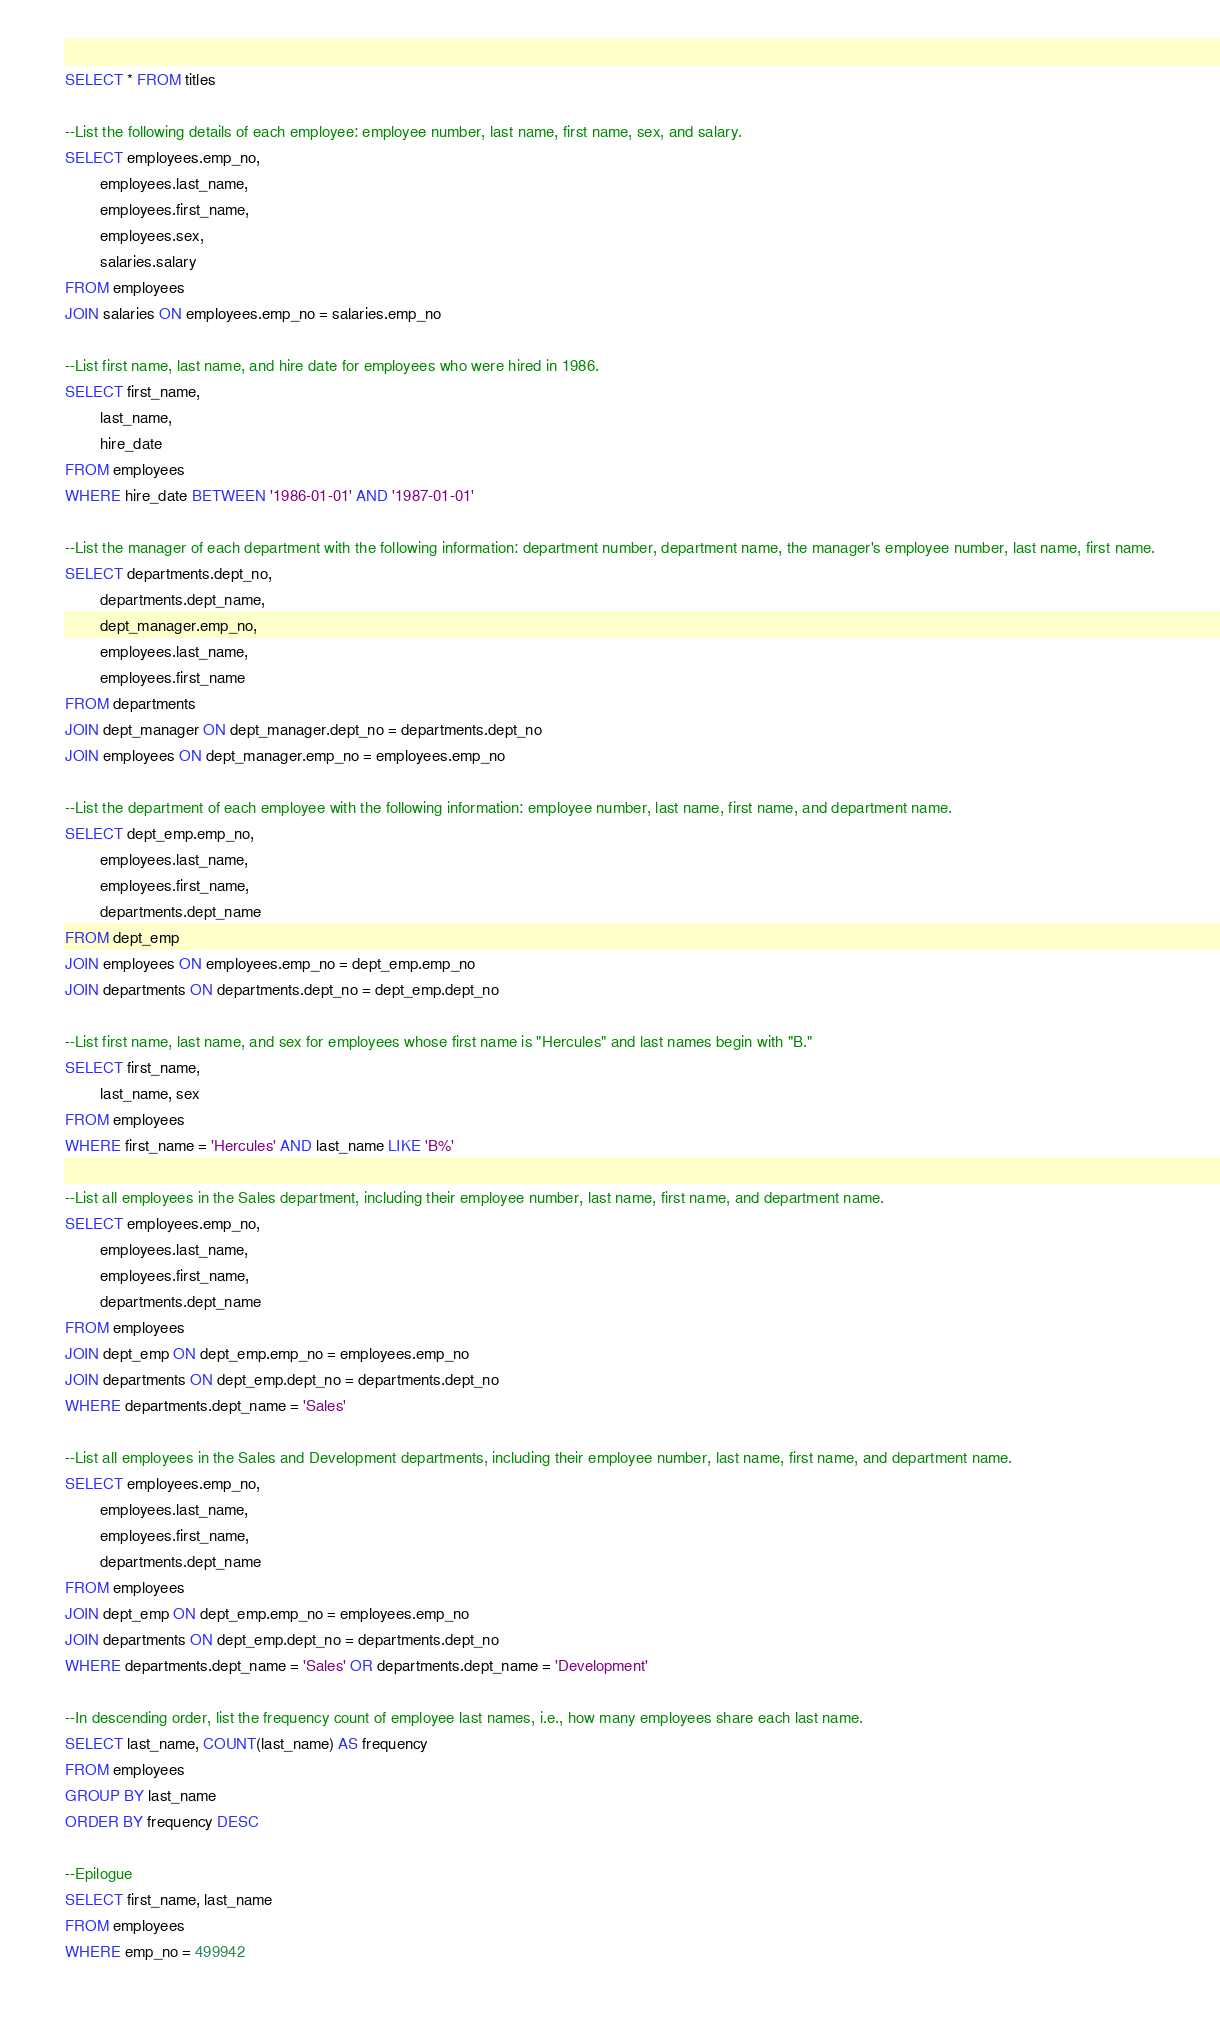Convert code to text. <code><loc_0><loc_0><loc_500><loc_500><_SQL_>SELECT * FROM titles

--List the following details of each employee: employee number, last name, first name, sex, and salary.
SELECT employees.emp_no,
		employees.last_name,
		employees.first_name,
		employees.sex,
		salaries.salary
FROM employees
JOIN salaries ON employees.emp_no = salaries.emp_no

--List first name, last name, and hire date for employees who were hired in 1986.
SELECT first_name,
		last_name,
		hire_date 
FROM employees
WHERE hire_date BETWEEN '1986-01-01' AND '1987-01-01'

--List the manager of each department with the following information: department number, department name, the manager's employee number, last name, first name.
SELECT departments.dept_no,
		departments.dept_name,
		dept_manager.emp_no,
		employees.last_name,
		employees.first_name
FROM departments
JOIN dept_manager ON dept_manager.dept_no = departments.dept_no
JOIN employees ON dept_manager.emp_no = employees.emp_no

--List the department of each employee with the following information: employee number, last name, first name, and department name.
SELECT dept_emp.emp_no,
		employees.last_name,
		employees.first_name,
		departments.dept_name
FROM dept_emp
JOIN employees ON employees.emp_no = dept_emp.emp_no
JOIN departments ON departments.dept_no = dept_emp.dept_no

--List first name, last name, and sex for employees whose first name is "Hercules" and last names begin with "B."
SELECT first_name,
		last_name, sex
FROM employees
WHERE first_name = 'Hercules' AND last_name LIKE 'B%'

--List all employees in the Sales department, including their employee number, last name, first name, and department name.
SELECT employees.emp_no,
		employees.last_name,
		employees.first_name,
		departments.dept_name
FROM employees
JOIN dept_emp ON dept_emp.emp_no = employees.emp_no
JOIN departments ON dept_emp.dept_no = departments.dept_no
WHERE departments.dept_name = 'Sales'

--List all employees in the Sales and Development departments, including their employee number, last name, first name, and department name.
SELECT employees.emp_no,
		employees.last_name,
		employees.first_name,
		departments.dept_name
FROM employees
JOIN dept_emp ON dept_emp.emp_no = employees.emp_no
JOIN departments ON dept_emp.dept_no = departments.dept_no
WHERE departments.dept_name = 'Sales' OR departments.dept_name = 'Development'

--In descending order, list the frequency count of employee last names, i.e., how many employees share each last name.
SELECT last_name, COUNT(last_name) AS frequency
FROM employees
GROUP BY last_name
ORDER BY frequency DESC

--Epilogue
SELECT first_name, last_name
FROM employees
WHERE emp_no = 499942</code> 